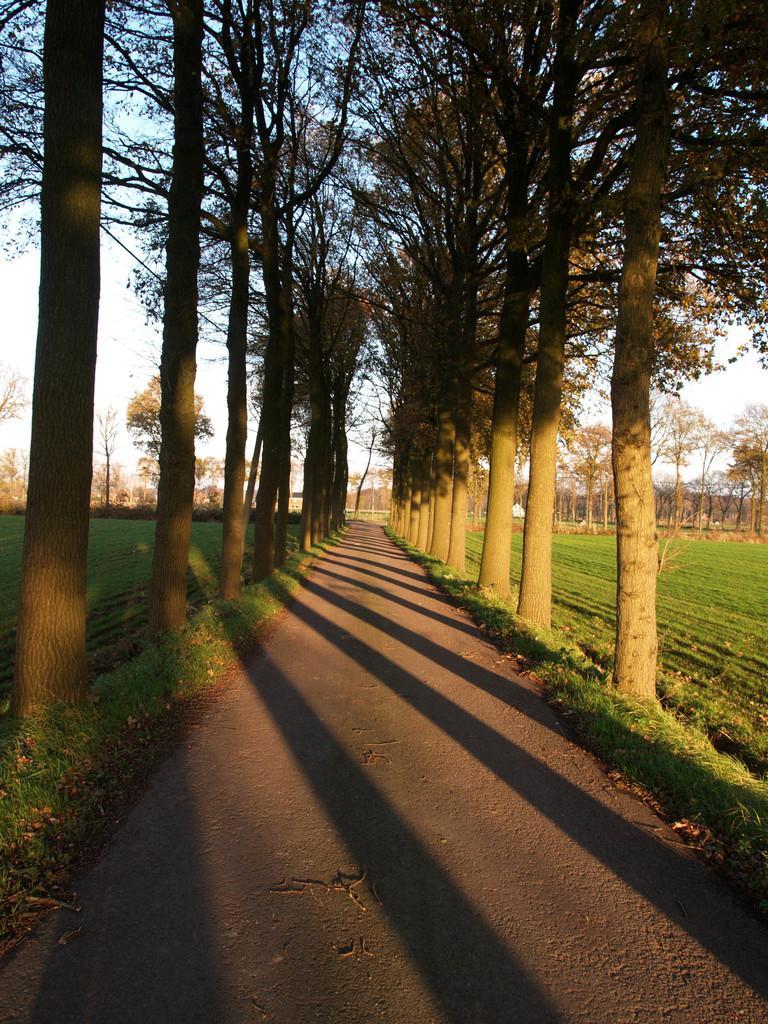Can you describe this image briefly? In this image there is a road, on either side of the road there are trees and fields. 